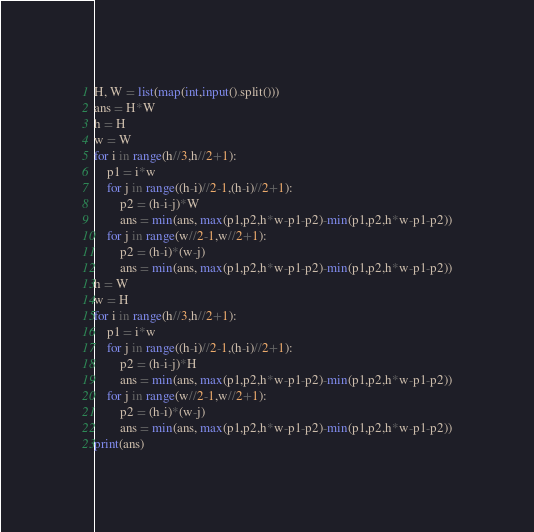Convert code to text. <code><loc_0><loc_0><loc_500><loc_500><_Python_>H, W = list(map(int,input().split()))
ans = H*W
h = H
w = W
for i in range(h//3,h//2+1):
    p1 = i*w
    for j in range((h-i)//2-1,(h-i)//2+1):
        p2 = (h-i-j)*W
        ans = min(ans, max(p1,p2,h*w-p1-p2)-min(p1,p2,h*w-p1-p2))
    for j in range(w//2-1,w//2+1):
        p2 = (h-i)*(w-j)
        ans = min(ans, max(p1,p2,h*w-p1-p2)-min(p1,p2,h*w-p1-p2))
h = W
w = H
for i in range(h//3,h//2+1):
    p1 = i*w
    for j in range((h-i)//2-1,(h-i)//2+1):
        p2 = (h-i-j)*H
        ans = min(ans, max(p1,p2,h*w-p1-p2)-min(p1,p2,h*w-p1-p2))
    for j in range(w//2-1,w//2+1):
        p2 = (h-i)*(w-j)
        ans = min(ans, max(p1,p2,h*w-p1-p2)-min(p1,p2,h*w-p1-p2))
print(ans)</code> 